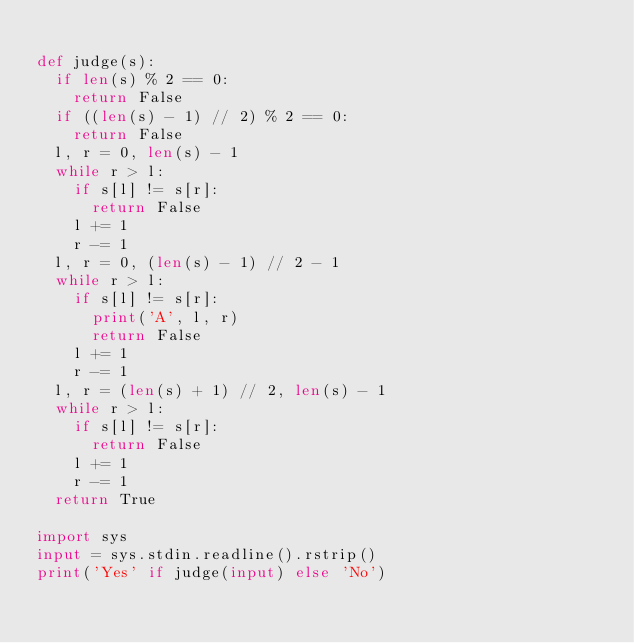<code> <loc_0><loc_0><loc_500><loc_500><_Python_>
def judge(s):
  if len(s) % 2 == 0:
    return False
  if ((len(s) - 1) // 2) % 2 == 0:
    return False
  l, r = 0, len(s) - 1
  while r > l:
    if s[l] != s[r]:
      return False
    l += 1
    r -= 1
  l, r = 0, (len(s) - 1) // 2 - 1
  while r > l:
    if s[l] != s[r]:
      print('A', l, r)
      return False
    l += 1
    r -= 1
  l, r = (len(s) + 1) // 2, len(s) - 1
  while r > l:
    if s[l] != s[r]:
      return False
    l += 1
    r -= 1
  return True

import sys
input = sys.stdin.readline().rstrip()
print('Yes' if judge(input) else 'No')
</code> 